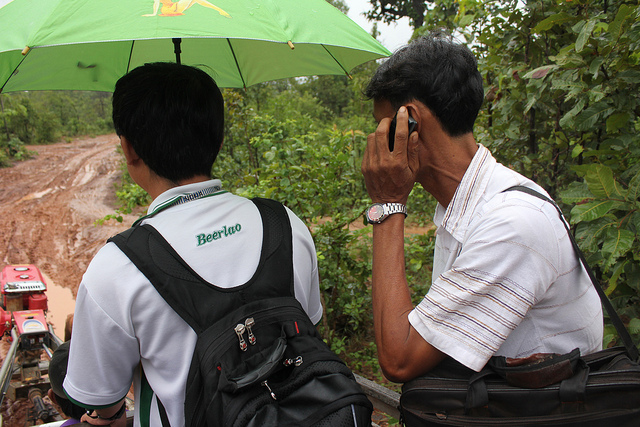Identify and read out the text in this image. Beerlao 